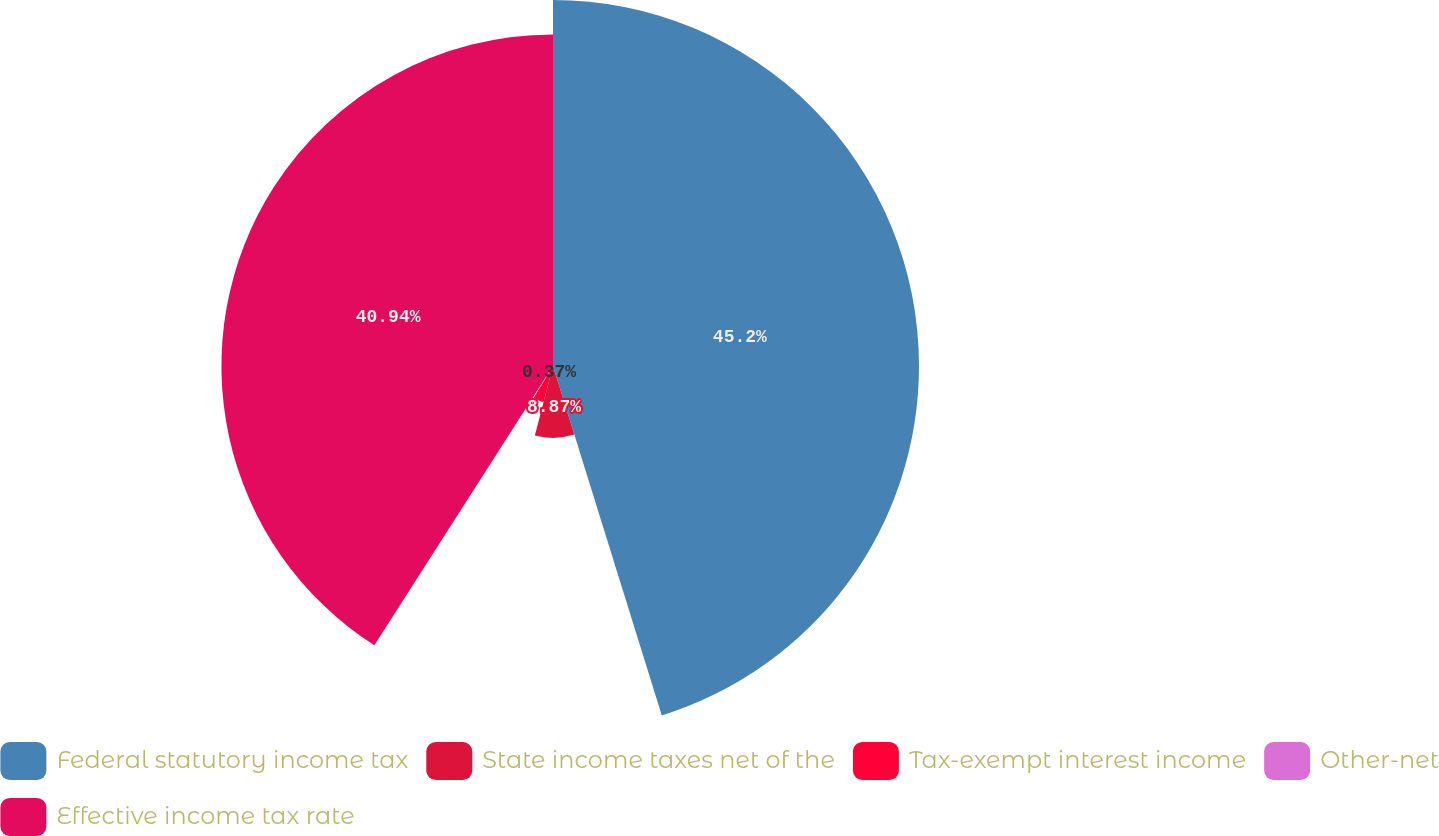Convert chart. <chart><loc_0><loc_0><loc_500><loc_500><pie_chart><fcel>Federal statutory income tax<fcel>State income taxes net of the<fcel>Tax-exempt interest income<fcel>Other-net<fcel>Effective income tax rate<nl><fcel>45.19%<fcel>8.87%<fcel>4.62%<fcel>0.37%<fcel>40.94%<nl></chart> 